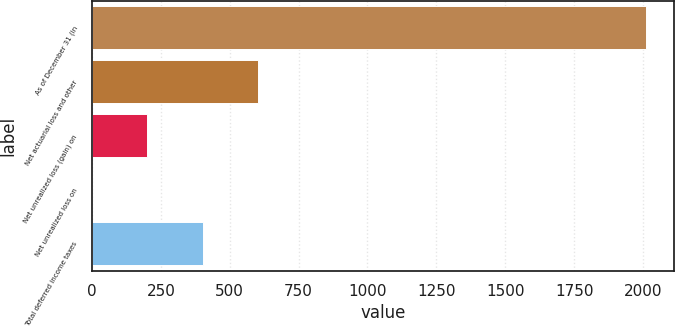Convert chart. <chart><loc_0><loc_0><loc_500><loc_500><bar_chart><fcel>As of December 31 (in<fcel>Net actuarial loss and other<fcel>Net unrealized loss (gain) on<fcel>Net unrealized loss on<fcel>Total deferred income taxes<nl><fcel>2011<fcel>603.37<fcel>201.19<fcel>0.1<fcel>402.28<nl></chart> 